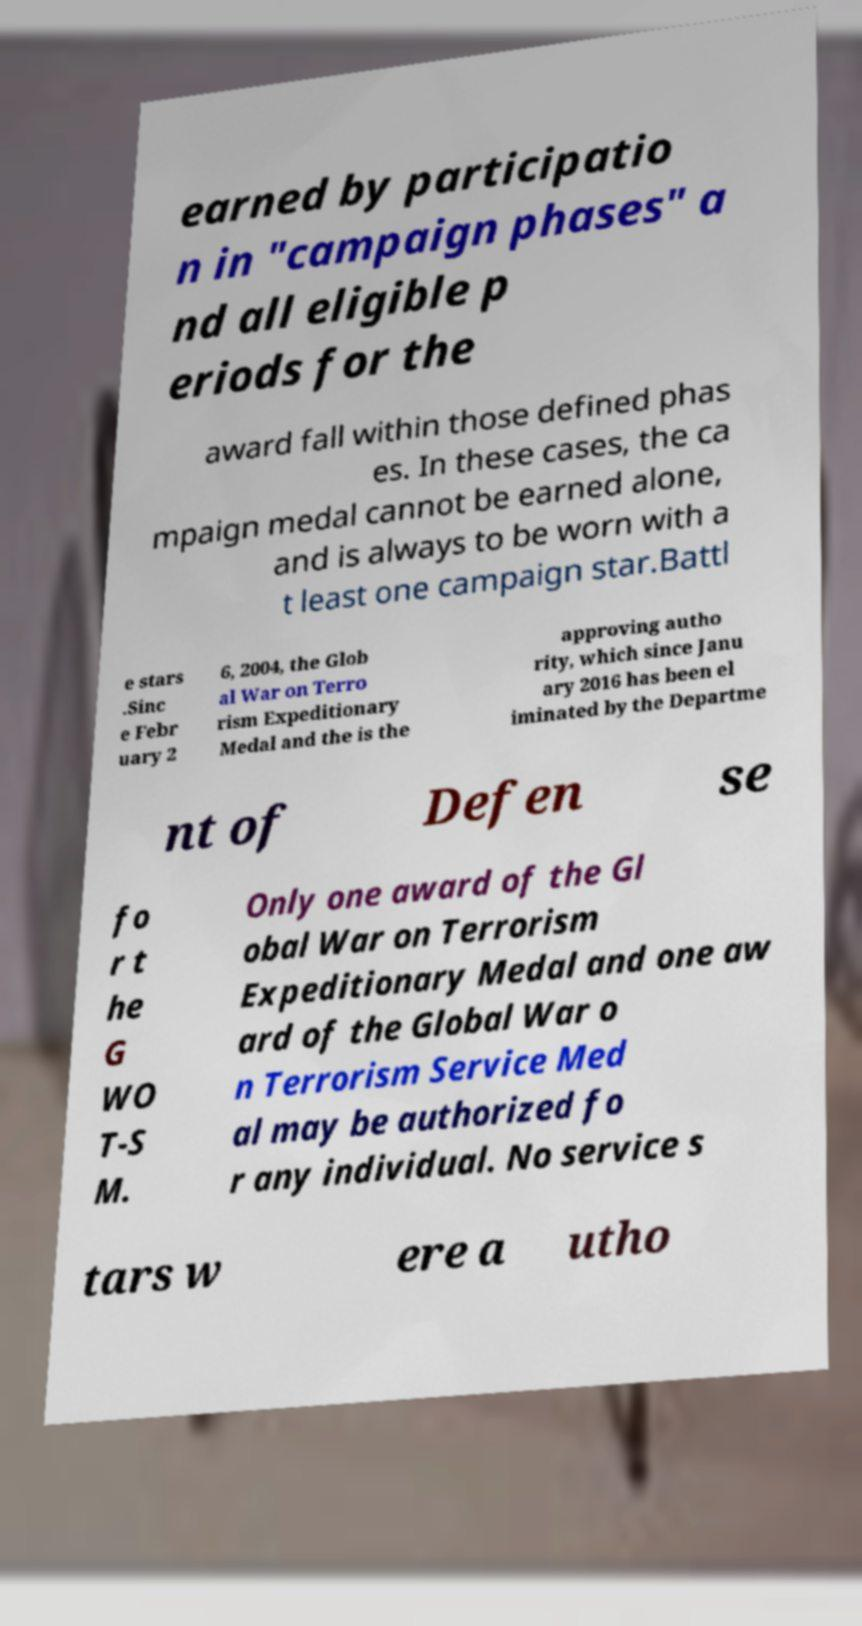What messages or text are displayed in this image? I need them in a readable, typed format. earned by participatio n in "campaign phases" a nd all eligible p eriods for the award fall within those defined phas es. In these cases, the ca mpaign medal cannot be earned alone, and is always to be worn with a t least one campaign star.Battl e stars .Sinc e Febr uary 2 6, 2004, the Glob al War on Terro rism Expeditionary Medal and the is the approving autho rity, which since Janu ary 2016 has been el iminated by the Departme nt of Defen se fo r t he G WO T-S M. Only one award of the Gl obal War on Terrorism Expeditionary Medal and one aw ard of the Global War o n Terrorism Service Med al may be authorized fo r any individual. No service s tars w ere a utho 